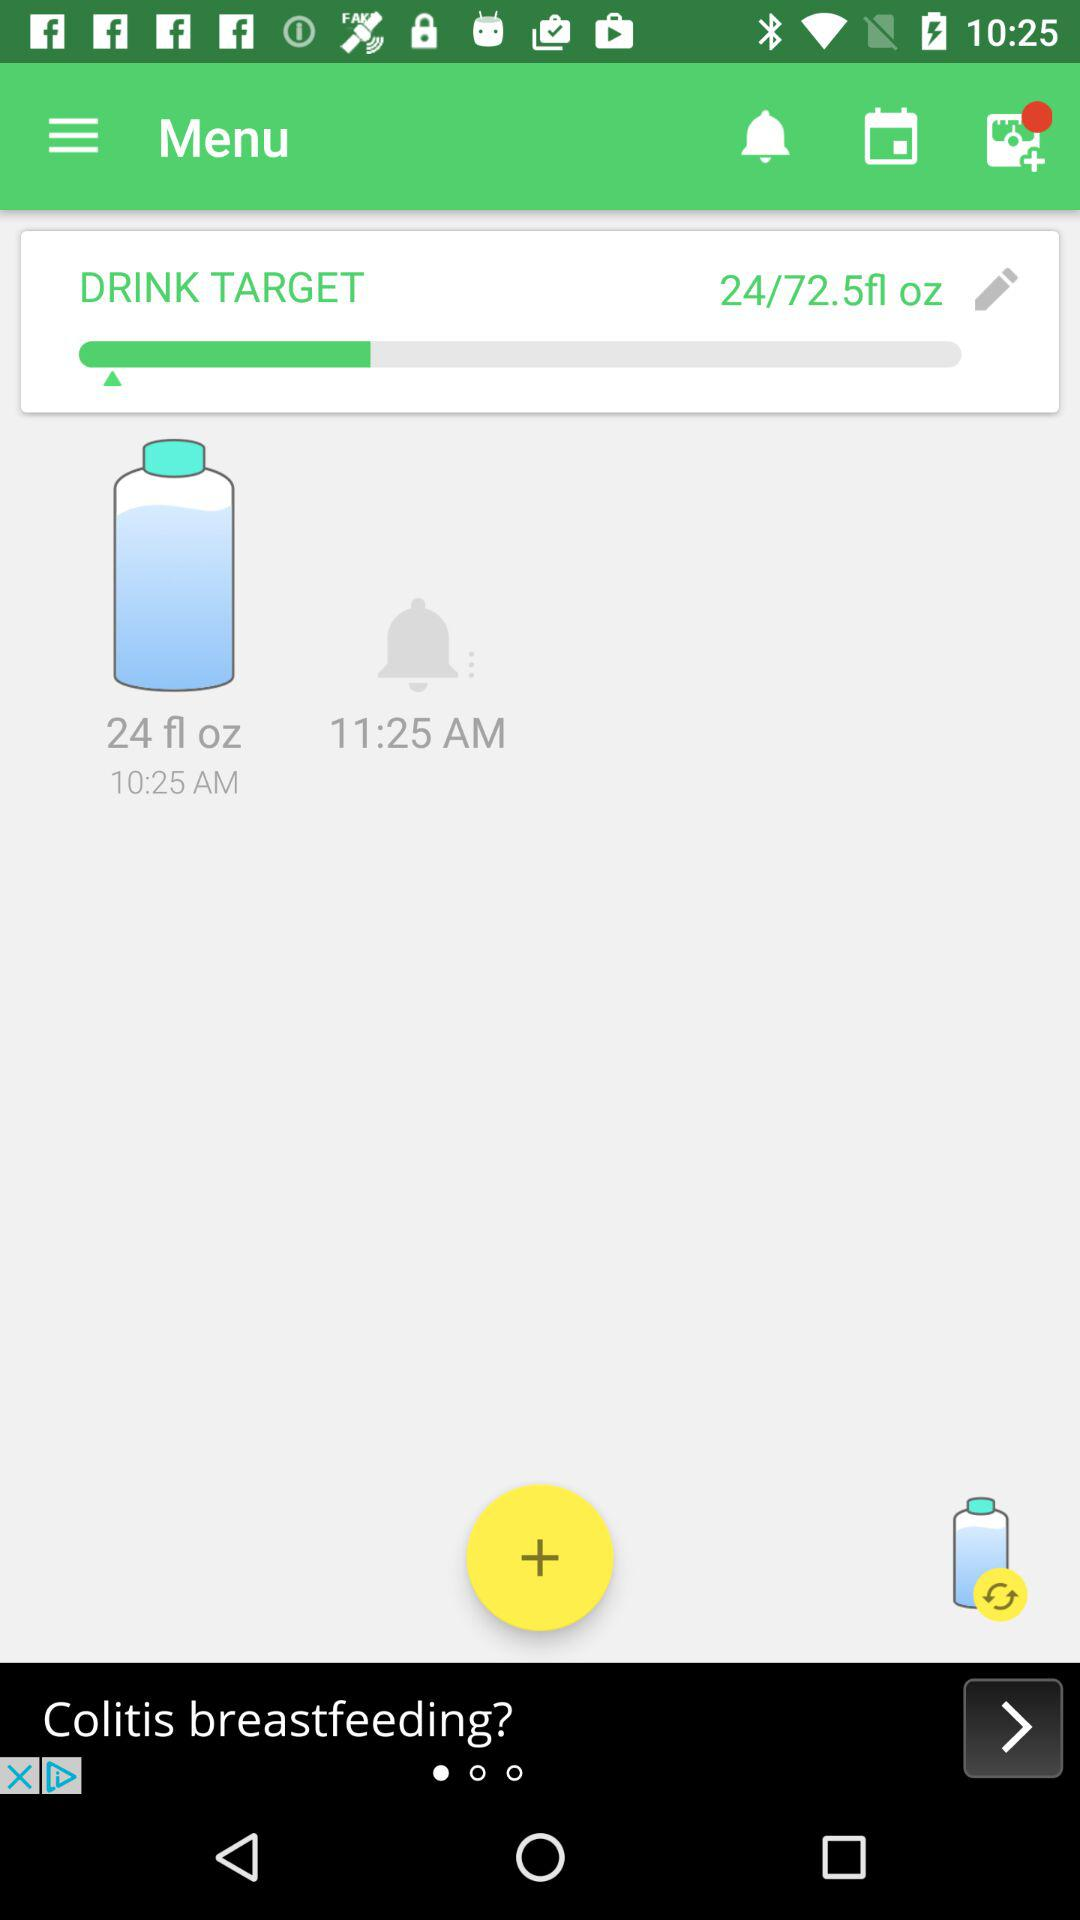How much of a drink target is achieved out of 72.5 fl oz? The achieved drink target is 24 fl oz. 